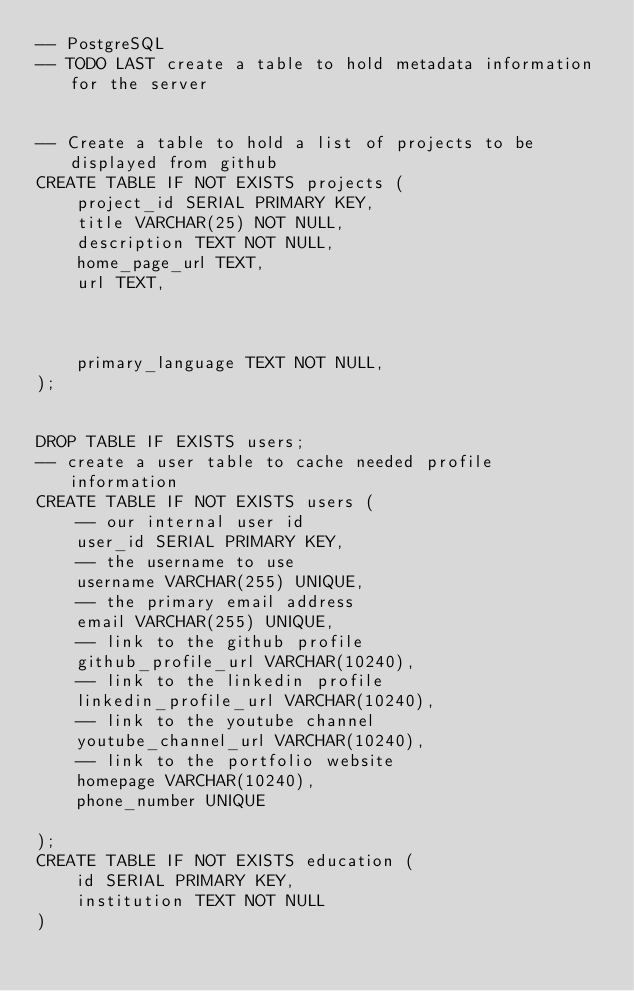Convert code to text. <code><loc_0><loc_0><loc_500><loc_500><_SQL_>-- PostgreSQL
-- TODO LAST create a table to hold metadata information for the server


-- Create a table to hold a list of projects to be displayed from github
CREATE TABLE IF NOT EXISTS projects (
    project_id SERIAL PRIMARY KEY,
    title VARCHAR(25) NOT NULL,
    description TEXT NOT NULL,
    home_page_url TEXT,
    url TEXT,



    primary_language TEXT NOT NULL,
);


DROP TABLE IF EXISTS users;
-- create a user table to cache needed profile information
CREATE TABLE IF NOT EXISTS users (
    -- our internal user id
    user_id SERIAL PRIMARY KEY,
    -- the username to use
    username VARCHAR(255) UNIQUE,
    -- the primary email address
    email VARCHAR(255) UNIQUE,
    -- link to the github profile
    github_profile_url VARCHAR(10240),
    -- link to the linkedin profile
    linkedin_profile_url VARCHAR(10240),
    -- link to the youtube channel
    youtube_channel_url VARCHAR(10240),
    -- link to the portfolio website
    homepage VARCHAR(10240),
    phone_number UNIQUE

);
CREATE TABLE IF NOT EXISTS education (
    id SERIAL PRIMARY KEY,
    institution TEXT NOT NULL 
)</code> 